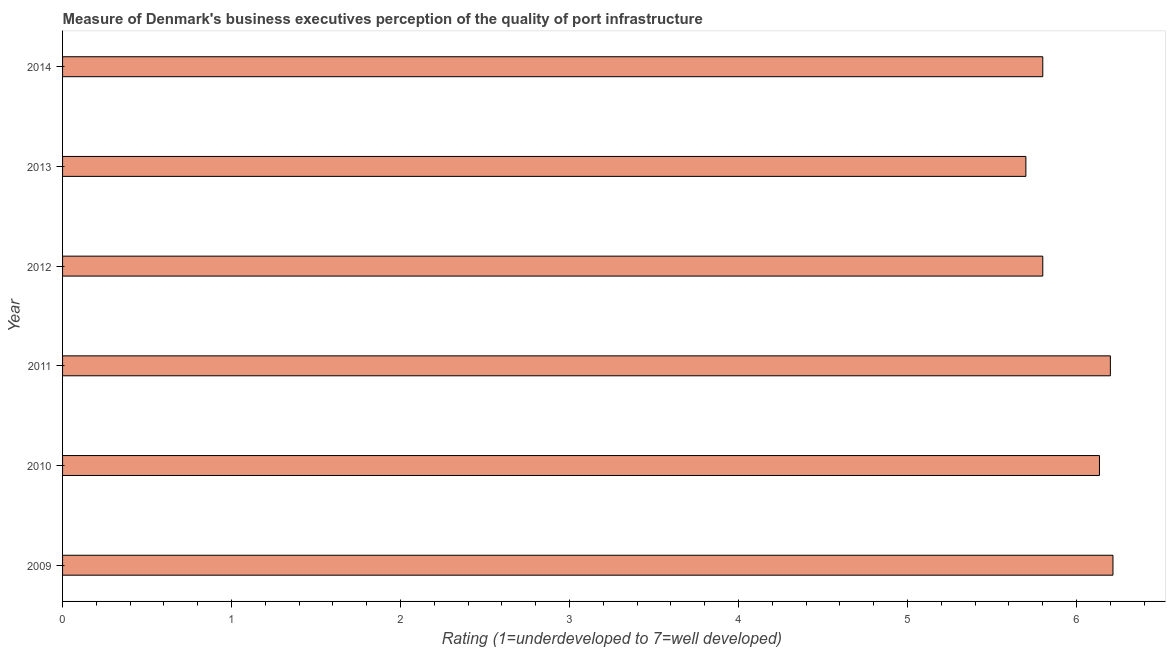Does the graph contain grids?
Provide a succinct answer. No. What is the title of the graph?
Offer a very short reply. Measure of Denmark's business executives perception of the quality of port infrastructure. What is the label or title of the X-axis?
Ensure brevity in your answer.  Rating (1=underdeveloped to 7=well developed) . What is the label or title of the Y-axis?
Make the answer very short. Year. What is the rating measuring quality of port infrastructure in 2013?
Your response must be concise. 5.7. Across all years, what is the maximum rating measuring quality of port infrastructure?
Your answer should be very brief. 6.22. In which year was the rating measuring quality of port infrastructure maximum?
Keep it short and to the point. 2009. What is the sum of the rating measuring quality of port infrastructure?
Provide a short and direct response. 35.85. What is the difference between the rating measuring quality of port infrastructure in 2010 and 2014?
Give a very brief answer. 0.34. What is the average rating measuring quality of port infrastructure per year?
Keep it short and to the point. 5.97. What is the median rating measuring quality of port infrastructure?
Offer a very short reply. 5.97. In how many years, is the rating measuring quality of port infrastructure greater than 4.2 ?
Offer a terse response. 6. What is the ratio of the rating measuring quality of port infrastructure in 2011 to that in 2012?
Your response must be concise. 1.07. Is the difference between the rating measuring quality of port infrastructure in 2011 and 2013 greater than the difference between any two years?
Give a very brief answer. No. What is the difference between the highest and the second highest rating measuring quality of port infrastructure?
Offer a terse response. 0.01. Is the sum of the rating measuring quality of port infrastructure in 2009 and 2012 greater than the maximum rating measuring quality of port infrastructure across all years?
Your response must be concise. Yes. What is the difference between the highest and the lowest rating measuring quality of port infrastructure?
Ensure brevity in your answer.  0.52. In how many years, is the rating measuring quality of port infrastructure greater than the average rating measuring quality of port infrastructure taken over all years?
Keep it short and to the point. 3. How many bars are there?
Keep it short and to the point. 6. Are all the bars in the graph horizontal?
Make the answer very short. Yes. What is the difference between two consecutive major ticks on the X-axis?
Your answer should be compact. 1. Are the values on the major ticks of X-axis written in scientific E-notation?
Make the answer very short. No. What is the Rating (1=underdeveloped to 7=well developed)  in 2009?
Provide a succinct answer. 6.22. What is the Rating (1=underdeveloped to 7=well developed)  in 2010?
Provide a short and direct response. 6.14. What is the Rating (1=underdeveloped to 7=well developed)  of 2011?
Offer a terse response. 6.2. What is the Rating (1=underdeveloped to 7=well developed)  of 2013?
Provide a succinct answer. 5.7. What is the difference between the Rating (1=underdeveloped to 7=well developed)  in 2009 and 2010?
Make the answer very short. 0.08. What is the difference between the Rating (1=underdeveloped to 7=well developed)  in 2009 and 2011?
Provide a succinct answer. 0.02. What is the difference between the Rating (1=underdeveloped to 7=well developed)  in 2009 and 2012?
Your answer should be very brief. 0.42. What is the difference between the Rating (1=underdeveloped to 7=well developed)  in 2009 and 2013?
Ensure brevity in your answer.  0.52. What is the difference between the Rating (1=underdeveloped to 7=well developed)  in 2009 and 2014?
Offer a very short reply. 0.42. What is the difference between the Rating (1=underdeveloped to 7=well developed)  in 2010 and 2011?
Offer a very short reply. -0.06. What is the difference between the Rating (1=underdeveloped to 7=well developed)  in 2010 and 2012?
Your answer should be compact. 0.34. What is the difference between the Rating (1=underdeveloped to 7=well developed)  in 2010 and 2013?
Your response must be concise. 0.44. What is the difference between the Rating (1=underdeveloped to 7=well developed)  in 2010 and 2014?
Make the answer very short. 0.34. What is the difference between the Rating (1=underdeveloped to 7=well developed)  in 2011 and 2013?
Provide a short and direct response. 0.5. What is the difference between the Rating (1=underdeveloped to 7=well developed)  in 2012 and 2013?
Offer a very short reply. 0.1. What is the difference between the Rating (1=underdeveloped to 7=well developed)  in 2012 and 2014?
Ensure brevity in your answer.  0. What is the difference between the Rating (1=underdeveloped to 7=well developed)  in 2013 and 2014?
Offer a very short reply. -0.1. What is the ratio of the Rating (1=underdeveloped to 7=well developed)  in 2009 to that in 2010?
Your response must be concise. 1.01. What is the ratio of the Rating (1=underdeveloped to 7=well developed)  in 2009 to that in 2012?
Your answer should be very brief. 1.07. What is the ratio of the Rating (1=underdeveloped to 7=well developed)  in 2009 to that in 2013?
Ensure brevity in your answer.  1.09. What is the ratio of the Rating (1=underdeveloped to 7=well developed)  in 2009 to that in 2014?
Give a very brief answer. 1.07. What is the ratio of the Rating (1=underdeveloped to 7=well developed)  in 2010 to that in 2011?
Ensure brevity in your answer.  0.99. What is the ratio of the Rating (1=underdeveloped to 7=well developed)  in 2010 to that in 2012?
Your answer should be very brief. 1.06. What is the ratio of the Rating (1=underdeveloped to 7=well developed)  in 2010 to that in 2013?
Provide a short and direct response. 1.08. What is the ratio of the Rating (1=underdeveloped to 7=well developed)  in 2010 to that in 2014?
Give a very brief answer. 1.06. What is the ratio of the Rating (1=underdeveloped to 7=well developed)  in 2011 to that in 2012?
Offer a very short reply. 1.07. What is the ratio of the Rating (1=underdeveloped to 7=well developed)  in 2011 to that in 2013?
Ensure brevity in your answer.  1.09. What is the ratio of the Rating (1=underdeveloped to 7=well developed)  in 2011 to that in 2014?
Provide a short and direct response. 1.07. What is the ratio of the Rating (1=underdeveloped to 7=well developed)  in 2012 to that in 2013?
Keep it short and to the point. 1.02. What is the ratio of the Rating (1=underdeveloped to 7=well developed)  in 2013 to that in 2014?
Provide a succinct answer. 0.98. 